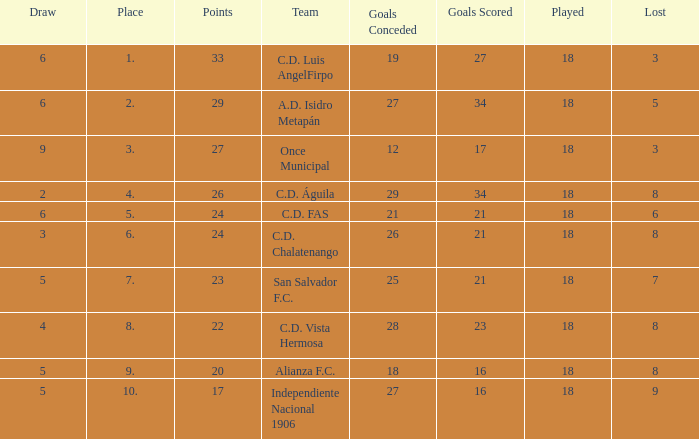What are the number of goals conceded that has a played greater than 18? 0.0. 